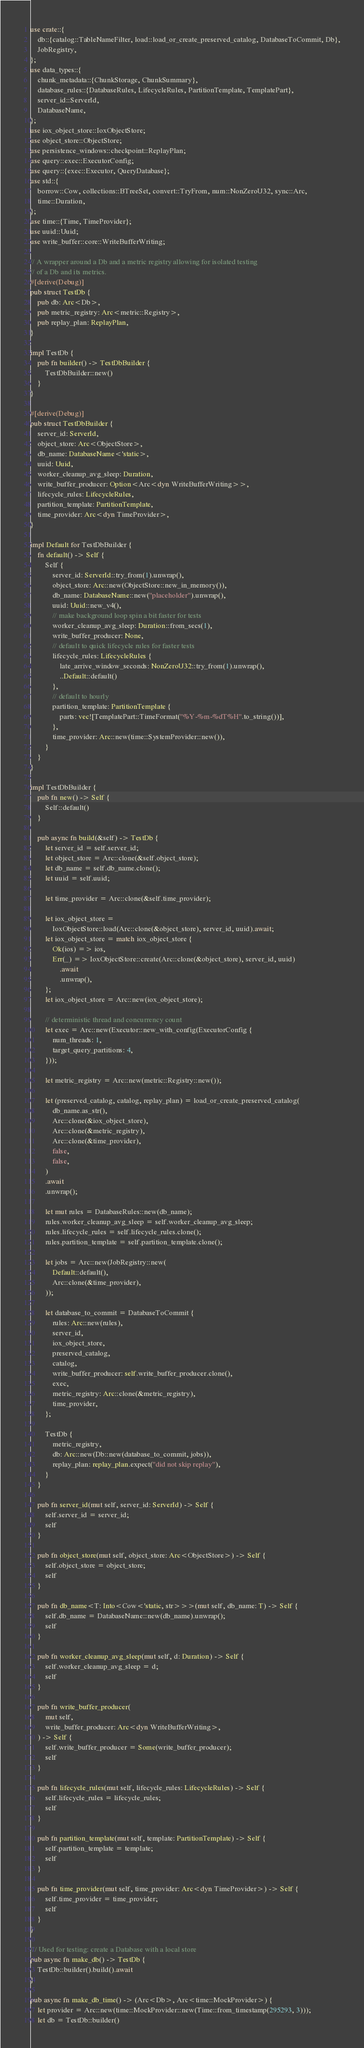Convert code to text. <code><loc_0><loc_0><loc_500><loc_500><_Rust_>use crate::{
    db::{catalog::TableNameFilter, load::load_or_create_preserved_catalog, DatabaseToCommit, Db},
    JobRegistry,
};
use data_types::{
    chunk_metadata::{ChunkStorage, ChunkSummary},
    database_rules::{DatabaseRules, LifecycleRules, PartitionTemplate, TemplatePart},
    server_id::ServerId,
    DatabaseName,
};
use iox_object_store::IoxObjectStore;
use object_store::ObjectStore;
use persistence_windows::checkpoint::ReplayPlan;
use query::exec::ExecutorConfig;
use query::{exec::Executor, QueryDatabase};
use std::{
    borrow::Cow, collections::BTreeSet, convert::TryFrom, num::NonZeroU32, sync::Arc,
    time::Duration,
};
use time::{Time, TimeProvider};
use uuid::Uuid;
use write_buffer::core::WriteBufferWriting;

// A wrapper around a Db and a metric registry allowing for isolated testing
// of a Db and its metrics.
#[derive(Debug)]
pub struct TestDb {
    pub db: Arc<Db>,
    pub metric_registry: Arc<metric::Registry>,
    pub replay_plan: ReplayPlan,
}

impl TestDb {
    pub fn builder() -> TestDbBuilder {
        TestDbBuilder::new()
    }
}

#[derive(Debug)]
pub struct TestDbBuilder {
    server_id: ServerId,
    object_store: Arc<ObjectStore>,
    db_name: DatabaseName<'static>,
    uuid: Uuid,
    worker_cleanup_avg_sleep: Duration,
    write_buffer_producer: Option<Arc<dyn WriteBufferWriting>>,
    lifecycle_rules: LifecycleRules,
    partition_template: PartitionTemplate,
    time_provider: Arc<dyn TimeProvider>,
}

impl Default for TestDbBuilder {
    fn default() -> Self {
        Self {
            server_id: ServerId::try_from(1).unwrap(),
            object_store: Arc::new(ObjectStore::new_in_memory()),
            db_name: DatabaseName::new("placeholder").unwrap(),
            uuid: Uuid::new_v4(),
            // make background loop spin a bit faster for tests
            worker_cleanup_avg_sleep: Duration::from_secs(1),
            write_buffer_producer: None,
            // default to quick lifecycle rules for faster tests
            lifecycle_rules: LifecycleRules {
                late_arrive_window_seconds: NonZeroU32::try_from(1).unwrap(),
                ..Default::default()
            },
            // default to hourly
            partition_template: PartitionTemplate {
                parts: vec![TemplatePart::TimeFormat("%Y-%m-%dT%H".to_string())],
            },
            time_provider: Arc::new(time::SystemProvider::new()),
        }
    }
}

impl TestDbBuilder {
    pub fn new() -> Self {
        Self::default()
    }

    pub async fn build(&self) -> TestDb {
        let server_id = self.server_id;
        let object_store = Arc::clone(&self.object_store);
        let db_name = self.db_name.clone();
        let uuid = self.uuid;

        let time_provider = Arc::clone(&self.time_provider);

        let iox_object_store =
            IoxObjectStore::load(Arc::clone(&object_store), server_id, uuid).await;
        let iox_object_store = match iox_object_store {
            Ok(ios) => ios,
            Err(_) => IoxObjectStore::create(Arc::clone(&object_store), server_id, uuid)
                .await
                .unwrap(),
        };
        let iox_object_store = Arc::new(iox_object_store);

        // deterministic thread and concurrency count
        let exec = Arc::new(Executor::new_with_config(ExecutorConfig {
            num_threads: 1,
            target_query_partitions: 4,
        }));

        let metric_registry = Arc::new(metric::Registry::new());

        let (preserved_catalog, catalog, replay_plan) = load_or_create_preserved_catalog(
            db_name.as_str(),
            Arc::clone(&iox_object_store),
            Arc::clone(&metric_registry),
            Arc::clone(&time_provider),
            false,
            false,
        )
        .await
        .unwrap();

        let mut rules = DatabaseRules::new(db_name);
        rules.worker_cleanup_avg_sleep = self.worker_cleanup_avg_sleep;
        rules.lifecycle_rules = self.lifecycle_rules.clone();
        rules.partition_template = self.partition_template.clone();

        let jobs = Arc::new(JobRegistry::new(
            Default::default(),
            Arc::clone(&time_provider),
        ));

        let database_to_commit = DatabaseToCommit {
            rules: Arc::new(rules),
            server_id,
            iox_object_store,
            preserved_catalog,
            catalog,
            write_buffer_producer: self.write_buffer_producer.clone(),
            exec,
            metric_registry: Arc::clone(&metric_registry),
            time_provider,
        };

        TestDb {
            metric_registry,
            db: Arc::new(Db::new(database_to_commit, jobs)),
            replay_plan: replay_plan.expect("did not skip replay"),
        }
    }

    pub fn server_id(mut self, server_id: ServerId) -> Self {
        self.server_id = server_id;
        self
    }

    pub fn object_store(mut self, object_store: Arc<ObjectStore>) -> Self {
        self.object_store = object_store;
        self
    }

    pub fn db_name<T: Into<Cow<'static, str>>>(mut self, db_name: T) -> Self {
        self.db_name = DatabaseName::new(db_name).unwrap();
        self
    }

    pub fn worker_cleanup_avg_sleep(mut self, d: Duration) -> Self {
        self.worker_cleanup_avg_sleep = d;
        self
    }

    pub fn write_buffer_producer(
        mut self,
        write_buffer_producer: Arc<dyn WriteBufferWriting>,
    ) -> Self {
        self.write_buffer_producer = Some(write_buffer_producer);
        self
    }

    pub fn lifecycle_rules(mut self, lifecycle_rules: LifecycleRules) -> Self {
        self.lifecycle_rules = lifecycle_rules;
        self
    }

    pub fn partition_template(mut self, template: PartitionTemplate) -> Self {
        self.partition_template = template;
        self
    }

    pub fn time_provider(mut self, time_provider: Arc<dyn TimeProvider>) -> Self {
        self.time_provider = time_provider;
        self
    }
}

/// Used for testing: create a Database with a local store
pub async fn make_db() -> TestDb {
    TestDb::builder().build().await
}

pub async fn make_db_time() -> (Arc<Db>, Arc<time::MockProvider>) {
    let provider = Arc::new(time::MockProvider::new(Time::from_timestamp(295293, 3)));
    let db = TestDb::builder()</code> 